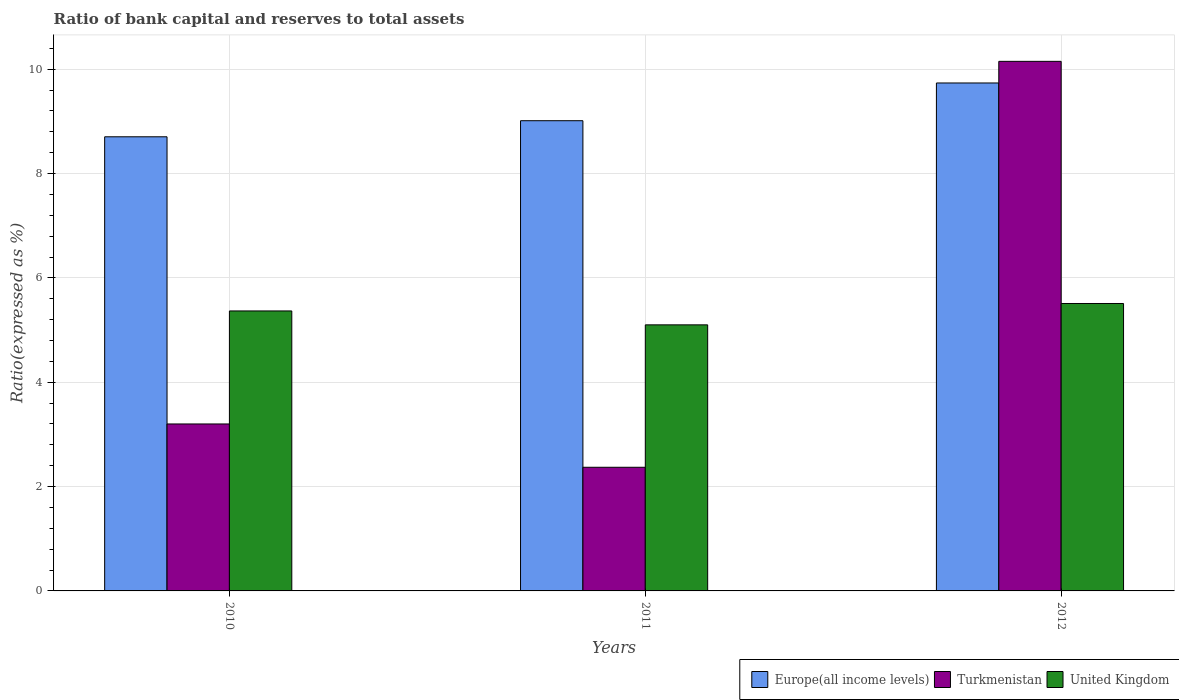How many different coloured bars are there?
Ensure brevity in your answer.  3. Are the number of bars per tick equal to the number of legend labels?
Your answer should be very brief. Yes. How many bars are there on the 3rd tick from the right?
Your response must be concise. 3. What is the label of the 1st group of bars from the left?
Keep it short and to the point. 2010. What is the ratio of bank capital and reserves to total assets in Turkmenistan in 2011?
Your response must be concise. 2.37. Across all years, what is the maximum ratio of bank capital and reserves to total assets in Europe(all income levels)?
Ensure brevity in your answer.  9.74. Across all years, what is the minimum ratio of bank capital and reserves to total assets in Europe(all income levels)?
Offer a terse response. 8.7. In which year was the ratio of bank capital and reserves to total assets in Turkmenistan minimum?
Your answer should be compact. 2011. What is the total ratio of bank capital and reserves to total assets in Turkmenistan in the graph?
Your answer should be very brief. 15.72. What is the difference between the ratio of bank capital and reserves to total assets in Turkmenistan in 2010 and that in 2012?
Ensure brevity in your answer.  -6.95. What is the difference between the ratio of bank capital and reserves to total assets in United Kingdom in 2011 and the ratio of bank capital and reserves to total assets in Turkmenistan in 2012?
Keep it short and to the point. -5.05. What is the average ratio of bank capital and reserves to total assets in Turkmenistan per year?
Give a very brief answer. 5.24. In the year 2010, what is the difference between the ratio of bank capital and reserves to total assets in United Kingdom and ratio of bank capital and reserves to total assets in Turkmenistan?
Your response must be concise. 2.17. In how many years, is the ratio of bank capital and reserves to total assets in Europe(all income levels) greater than 8.4 %?
Keep it short and to the point. 3. What is the ratio of the ratio of bank capital and reserves to total assets in United Kingdom in 2011 to that in 2012?
Make the answer very short. 0.93. Is the ratio of bank capital and reserves to total assets in Turkmenistan in 2011 less than that in 2012?
Make the answer very short. Yes. Is the difference between the ratio of bank capital and reserves to total assets in United Kingdom in 2010 and 2012 greater than the difference between the ratio of bank capital and reserves to total assets in Turkmenistan in 2010 and 2012?
Offer a very short reply. Yes. What is the difference between the highest and the second highest ratio of bank capital and reserves to total assets in Turkmenistan?
Ensure brevity in your answer.  6.95. What is the difference between the highest and the lowest ratio of bank capital and reserves to total assets in Europe(all income levels)?
Give a very brief answer. 1.03. Is the sum of the ratio of bank capital and reserves to total assets in Europe(all income levels) in 2010 and 2012 greater than the maximum ratio of bank capital and reserves to total assets in Turkmenistan across all years?
Your answer should be compact. Yes. What does the 2nd bar from the left in 2011 represents?
Offer a terse response. Turkmenistan. Is it the case that in every year, the sum of the ratio of bank capital and reserves to total assets in Turkmenistan and ratio of bank capital and reserves to total assets in United Kingdom is greater than the ratio of bank capital and reserves to total assets in Europe(all income levels)?
Your answer should be very brief. No. How many years are there in the graph?
Offer a terse response. 3. Does the graph contain any zero values?
Provide a succinct answer. No. Does the graph contain grids?
Offer a terse response. Yes. How many legend labels are there?
Give a very brief answer. 3. What is the title of the graph?
Ensure brevity in your answer.  Ratio of bank capital and reserves to total assets. What is the label or title of the Y-axis?
Offer a terse response. Ratio(expressed as %). What is the Ratio(expressed as %) in Europe(all income levels) in 2010?
Your answer should be compact. 8.7. What is the Ratio(expressed as %) in United Kingdom in 2010?
Make the answer very short. 5.37. What is the Ratio(expressed as %) in Europe(all income levels) in 2011?
Ensure brevity in your answer.  9.01. What is the Ratio(expressed as %) in Turkmenistan in 2011?
Provide a short and direct response. 2.37. What is the Ratio(expressed as %) of United Kingdom in 2011?
Provide a short and direct response. 5.1. What is the Ratio(expressed as %) of Europe(all income levels) in 2012?
Give a very brief answer. 9.74. What is the Ratio(expressed as %) of Turkmenistan in 2012?
Provide a succinct answer. 10.15. What is the Ratio(expressed as %) of United Kingdom in 2012?
Offer a terse response. 5.51. Across all years, what is the maximum Ratio(expressed as %) in Europe(all income levels)?
Provide a succinct answer. 9.74. Across all years, what is the maximum Ratio(expressed as %) in Turkmenistan?
Make the answer very short. 10.15. Across all years, what is the maximum Ratio(expressed as %) of United Kingdom?
Provide a succinct answer. 5.51. Across all years, what is the minimum Ratio(expressed as %) of Europe(all income levels)?
Make the answer very short. 8.7. Across all years, what is the minimum Ratio(expressed as %) in Turkmenistan?
Provide a short and direct response. 2.37. Across all years, what is the minimum Ratio(expressed as %) of United Kingdom?
Give a very brief answer. 5.1. What is the total Ratio(expressed as %) in Europe(all income levels) in the graph?
Make the answer very short. 27.45. What is the total Ratio(expressed as %) of Turkmenistan in the graph?
Make the answer very short. 15.72. What is the total Ratio(expressed as %) in United Kingdom in the graph?
Keep it short and to the point. 15.97. What is the difference between the Ratio(expressed as %) in Europe(all income levels) in 2010 and that in 2011?
Give a very brief answer. -0.31. What is the difference between the Ratio(expressed as %) of Turkmenistan in 2010 and that in 2011?
Your response must be concise. 0.83. What is the difference between the Ratio(expressed as %) of United Kingdom in 2010 and that in 2011?
Your answer should be very brief. 0.27. What is the difference between the Ratio(expressed as %) in Europe(all income levels) in 2010 and that in 2012?
Your response must be concise. -1.03. What is the difference between the Ratio(expressed as %) in Turkmenistan in 2010 and that in 2012?
Make the answer very short. -6.95. What is the difference between the Ratio(expressed as %) in United Kingdom in 2010 and that in 2012?
Offer a terse response. -0.14. What is the difference between the Ratio(expressed as %) of Europe(all income levels) in 2011 and that in 2012?
Your answer should be compact. -0.72. What is the difference between the Ratio(expressed as %) in Turkmenistan in 2011 and that in 2012?
Offer a very short reply. -7.78. What is the difference between the Ratio(expressed as %) in United Kingdom in 2011 and that in 2012?
Give a very brief answer. -0.41. What is the difference between the Ratio(expressed as %) of Europe(all income levels) in 2010 and the Ratio(expressed as %) of Turkmenistan in 2011?
Ensure brevity in your answer.  6.33. What is the difference between the Ratio(expressed as %) of Europe(all income levels) in 2010 and the Ratio(expressed as %) of United Kingdom in 2011?
Provide a short and direct response. 3.6. What is the difference between the Ratio(expressed as %) in Turkmenistan in 2010 and the Ratio(expressed as %) in United Kingdom in 2011?
Provide a short and direct response. -1.9. What is the difference between the Ratio(expressed as %) in Europe(all income levels) in 2010 and the Ratio(expressed as %) in Turkmenistan in 2012?
Offer a terse response. -1.45. What is the difference between the Ratio(expressed as %) of Europe(all income levels) in 2010 and the Ratio(expressed as %) of United Kingdom in 2012?
Your answer should be compact. 3.2. What is the difference between the Ratio(expressed as %) of Turkmenistan in 2010 and the Ratio(expressed as %) of United Kingdom in 2012?
Ensure brevity in your answer.  -2.31. What is the difference between the Ratio(expressed as %) of Europe(all income levels) in 2011 and the Ratio(expressed as %) of Turkmenistan in 2012?
Your response must be concise. -1.14. What is the difference between the Ratio(expressed as %) of Europe(all income levels) in 2011 and the Ratio(expressed as %) of United Kingdom in 2012?
Your response must be concise. 3.5. What is the difference between the Ratio(expressed as %) of Turkmenistan in 2011 and the Ratio(expressed as %) of United Kingdom in 2012?
Offer a very short reply. -3.14. What is the average Ratio(expressed as %) of Europe(all income levels) per year?
Offer a very short reply. 9.15. What is the average Ratio(expressed as %) in Turkmenistan per year?
Keep it short and to the point. 5.24. What is the average Ratio(expressed as %) in United Kingdom per year?
Your response must be concise. 5.32. In the year 2010, what is the difference between the Ratio(expressed as %) of Europe(all income levels) and Ratio(expressed as %) of Turkmenistan?
Your response must be concise. 5.5. In the year 2010, what is the difference between the Ratio(expressed as %) of Europe(all income levels) and Ratio(expressed as %) of United Kingdom?
Your answer should be compact. 3.34. In the year 2010, what is the difference between the Ratio(expressed as %) of Turkmenistan and Ratio(expressed as %) of United Kingdom?
Make the answer very short. -2.17. In the year 2011, what is the difference between the Ratio(expressed as %) in Europe(all income levels) and Ratio(expressed as %) in Turkmenistan?
Your response must be concise. 6.64. In the year 2011, what is the difference between the Ratio(expressed as %) of Europe(all income levels) and Ratio(expressed as %) of United Kingdom?
Make the answer very short. 3.91. In the year 2011, what is the difference between the Ratio(expressed as %) of Turkmenistan and Ratio(expressed as %) of United Kingdom?
Ensure brevity in your answer.  -2.73. In the year 2012, what is the difference between the Ratio(expressed as %) in Europe(all income levels) and Ratio(expressed as %) in Turkmenistan?
Make the answer very short. -0.41. In the year 2012, what is the difference between the Ratio(expressed as %) of Europe(all income levels) and Ratio(expressed as %) of United Kingdom?
Keep it short and to the point. 4.23. In the year 2012, what is the difference between the Ratio(expressed as %) of Turkmenistan and Ratio(expressed as %) of United Kingdom?
Give a very brief answer. 4.64. What is the ratio of the Ratio(expressed as %) of Europe(all income levels) in 2010 to that in 2011?
Ensure brevity in your answer.  0.97. What is the ratio of the Ratio(expressed as %) of Turkmenistan in 2010 to that in 2011?
Offer a terse response. 1.35. What is the ratio of the Ratio(expressed as %) of United Kingdom in 2010 to that in 2011?
Make the answer very short. 1.05. What is the ratio of the Ratio(expressed as %) in Europe(all income levels) in 2010 to that in 2012?
Make the answer very short. 0.89. What is the ratio of the Ratio(expressed as %) in Turkmenistan in 2010 to that in 2012?
Offer a very short reply. 0.32. What is the ratio of the Ratio(expressed as %) in United Kingdom in 2010 to that in 2012?
Keep it short and to the point. 0.97. What is the ratio of the Ratio(expressed as %) of Europe(all income levels) in 2011 to that in 2012?
Ensure brevity in your answer.  0.93. What is the ratio of the Ratio(expressed as %) in Turkmenistan in 2011 to that in 2012?
Provide a succinct answer. 0.23. What is the ratio of the Ratio(expressed as %) of United Kingdom in 2011 to that in 2012?
Give a very brief answer. 0.93. What is the difference between the highest and the second highest Ratio(expressed as %) in Europe(all income levels)?
Give a very brief answer. 0.72. What is the difference between the highest and the second highest Ratio(expressed as %) in Turkmenistan?
Keep it short and to the point. 6.95. What is the difference between the highest and the second highest Ratio(expressed as %) in United Kingdom?
Your answer should be compact. 0.14. What is the difference between the highest and the lowest Ratio(expressed as %) in Europe(all income levels)?
Provide a short and direct response. 1.03. What is the difference between the highest and the lowest Ratio(expressed as %) in Turkmenistan?
Offer a terse response. 7.78. What is the difference between the highest and the lowest Ratio(expressed as %) of United Kingdom?
Offer a very short reply. 0.41. 